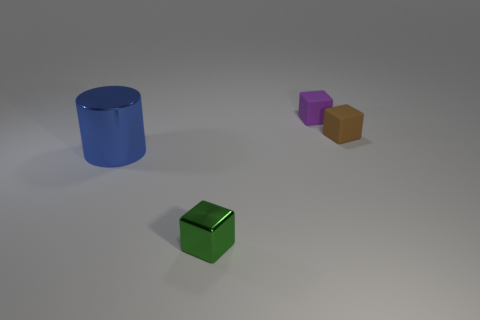How many things are either shiny things behind the small shiny block or cubes that are on the right side of the small green metallic block?
Give a very brief answer. 3. Are there the same number of rubber blocks in front of the green metallic thing and tiny matte objects that are on the left side of the tiny purple thing?
Give a very brief answer. Yes. The object that is right of the purple block is what color?
Your answer should be compact. Brown. Do the metallic block and the rubber thing to the left of the brown matte block have the same color?
Keep it short and to the point. No. Is the number of big metallic things less than the number of tiny things?
Provide a short and direct response. Yes. Do the metallic object on the right side of the cylinder and the cylinder have the same color?
Offer a terse response. No. What number of metallic blocks have the same size as the blue metallic cylinder?
Provide a short and direct response. 0. Are there any cylinders that have the same color as the large object?
Offer a terse response. No. Does the brown cube have the same material as the big blue object?
Offer a terse response. No. How many small purple rubber objects have the same shape as the large blue metallic object?
Offer a terse response. 0. 